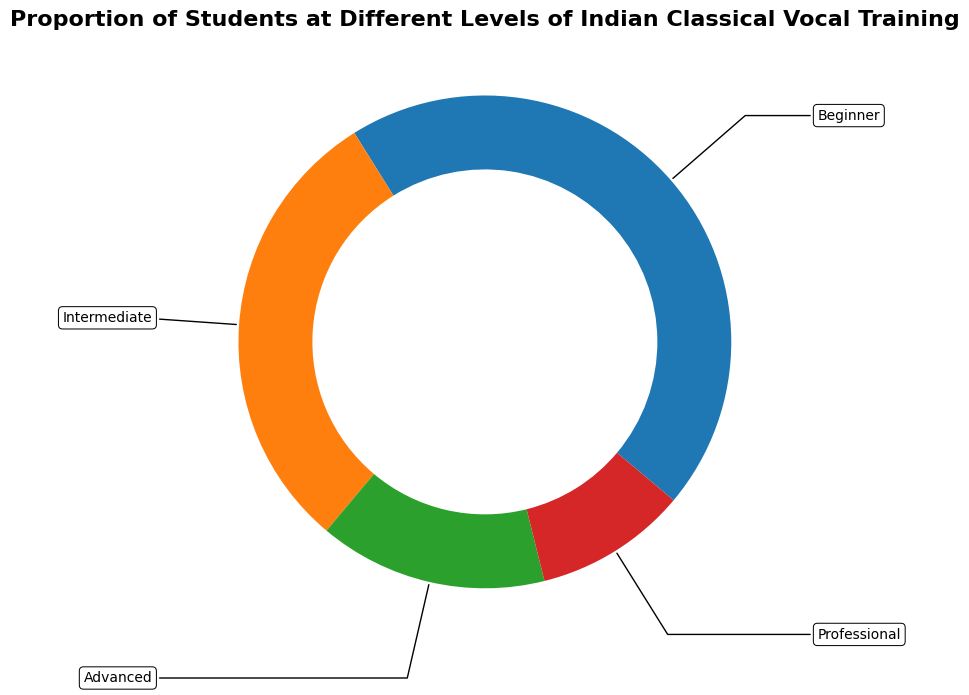What proportion of students are at the intermediate and professional levels combined? First, identify the proportions of students at the intermediate (0.30) and professional (0.10) levels from the figure. Then, sum these two proportions: 0.30 + 0.10 = 0.40
Answer: 0.40 Which level has the smallest proportion of students? From the figure, locate the level with the smallest wedge area. The smallest proportion is 0.10, which corresponds to the professional level.
Answer: Professional Out of 100 students, how many would be at the beginner level? The proportion of beginner students is 0.45. Multiply this proportion by 100 students: 0.45 * 100 = 45.
Answer: 45 Is the proportion of advanced students greater than half the proportion of beginner students? The proportion of advanced students is 0.15, and half the proportion of beginner students is 0.45 / 2 = 0.225. Since 0.15 < 0.225, the proportion of advanced students is not greater.
Answer: No What is the difference in proportions between the beginner and intermediate levels? Identify the proportions of beginner (0.45) and intermediate (0.30) levels from the figure. Subtract the intermediate proportion from the beginner proportion: 0.45 - 0.30 = 0.15.
Answer: 0.15 If there were 200 students in total, how many would be at the advanced level? The proportion of advanced students is 0.15. Multiply this proportion by 200 students: 0.15 * 200 = 30.
Answer: 30 Which levels have a combined proportion equal to or greater than the beginner level? The beginner level has a proportion of 0.45. The combination of intermediate and professional levels has a proportion of 0.30 + 0.10 = 0.40, which is less. The combination of intermediate and advanced levels has a proportion of 0.30 + 0.15 = 0.45, which is equal. Therefore, intermediate and advanced levels combined meet the condition.
Answer: Intermediate and Advanced How does the proportion of intermediate students compare to the combined proportion of advanced and professional students? The proportion of intermediate students is 0.30. The combined proportion of advanced and professional students is 0.15 + 0.10 = 0.25. Since 0.30 > 0.25, the proportion of intermediate students is greater.
Answer: Greater What is the total proportion of students not at the professional level? The proportion of professional students is 0.10. Subtract this from the total proportion (1): 1 - 0.10 = 0.90.
Answer: 0.90 If the proportions represent percentages, what is the percentage difference between beginner and advanced levels? Convert the proportions to percentages: beginner (45%), advanced (15%). Subtract the advanced percentage from the beginner percentage: 45% - 15% = 30%.
Answer: 30% 